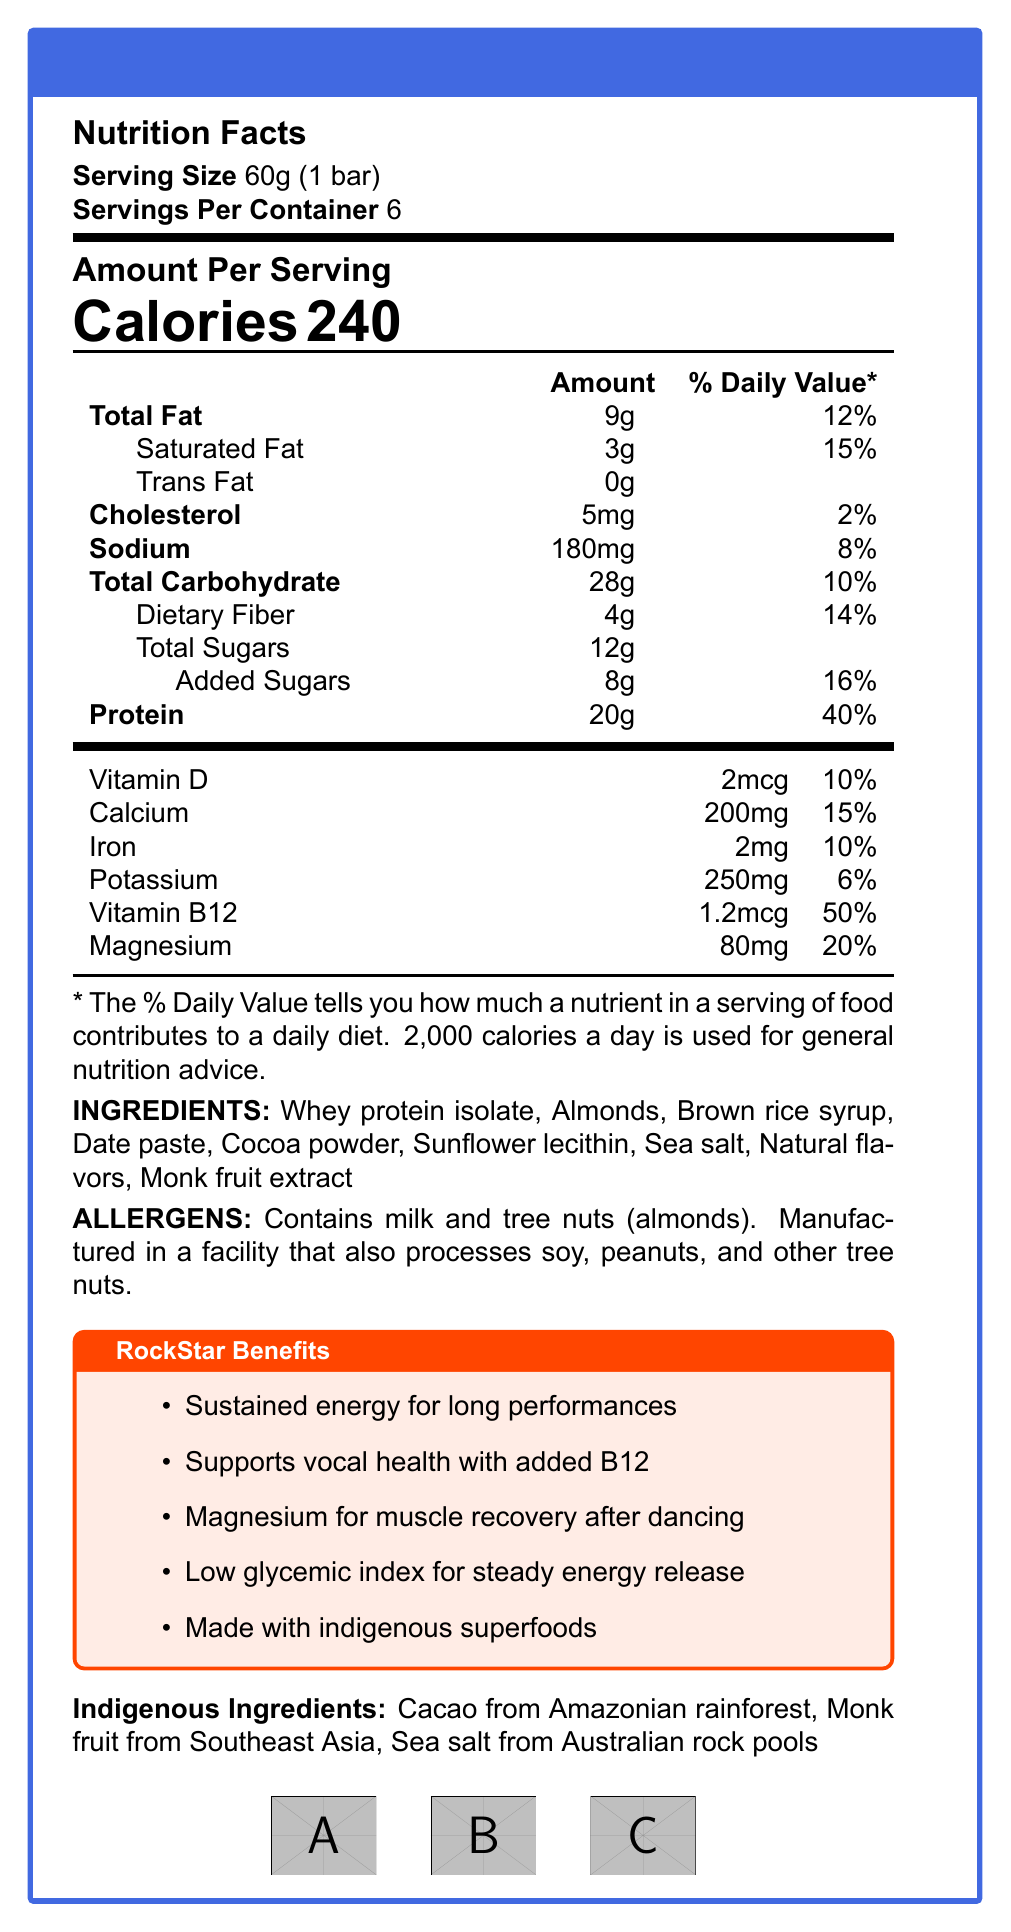What is the serving size of the RockStar Protein Bar? The document states that the serving size is 60g, which is equivalent to 1 bar.
Answer: 60g (1 bar) How many servings are there per container of the RockStar Protein Bar? The document mentions that there are 6 servings per container.
Answer: 6 How many calories are there per serving of the RockStar Protein Bar? The document states that there are 240 calories per serving.
Answer: 240 What is the amount of protein per serving in the RockStar Protein Bar? The nutrition facts indicate that each serving contains 20g of protein.
Answer: 20g What is the percentage of the daily value of saturated fat in each serving of the RockStar Protein Bar? The document lists the daily value percentage of saturated fat as 15%.
Answer: 15% Which ingredient is NOT listed as part of the RockStar Protein Bar? A. Whey protein isolate B. Almonds C. Brown sugar D. Date paste The document lists whey protein isolate, almonds, and date paste, but not brown sugar.
Answer: C. Brown sugar Which certification logo is NOT mentioned for the RockStar Protein Bar? A. Non-GMO Project Verified B. Organic Certified C. Fair Trade Certified D. Rainforest Alliance Certified The certification logos shown are Non-GMO Project Verified, Fair Trade Certified, and Rainforest Alliance Certified, but not Organic Certified.
Answer: B. Organic Certified Does the RockStar Protein Bar contain trans fat? The document clearly states that the amounts of trans fat are 0g.
Answer: No Is the RockStar Protein Bar manufactured in a facility that processes peanuts? The allergens section indicates that the product is manufactured in a facility that also processes soy, peanuts, and other tree nuts.
Answer: Yes Summarize the key nutritional benefits of the RockStar Protein Bar. The document emphasizes the protein bar’s nutritional benefits like sustained energy, vocal health support (with B12), muscle recovery (thanks to magnesium), and its low glycemic index. Additionally, it highlights the inclusion of indigenous superfoods and certification logos indicating quality and ethical practices.
Answer: The RockStar Protein Bar is a high-protein bar designed for sustained energy and vocal health, with added benefits for muscle recovery and steady energy release. It includes indigenous superfoods and is certified by multiple sustainability and fair trade organizations. What is the source of cacao used in the RockStar Protein Bar? The document states that the cacao is sourced from the Amazonian rainforest.
Answer: Amazonian rainforest How does the RockStar Protein Bar support vocal health? The document lists “Supports vocal health with added B12” under the RockStar Benefits section.
Answer: With added B12 Is there enough information to determine how much potassium the average person should consume daily? The document states the potassium content per serving (250mg and 6% daily value) but does not provide the total recommended daily intake.
Answer: Not enough information How much dietary fiber is there per serving and what percentage of the daily value does it represent? The nutrition facts indicate that each serving contains 4g of dietary fiber, which is 14% of the daily value.
Answer: 4g, 14% 